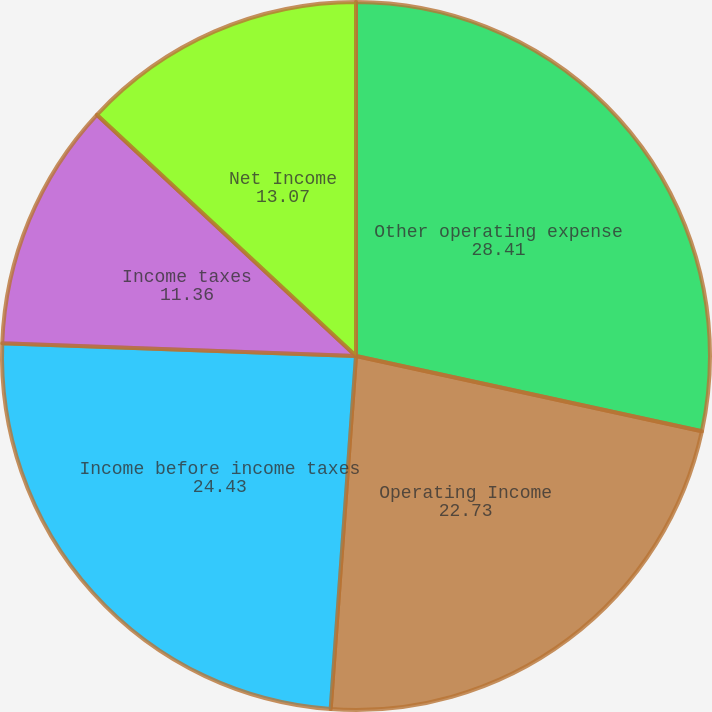Convert chart. <chart><loc_0><loc_0><loc_500><loc_500><pie_chart><fcel>Other operating expense<fcel>Operating Income<fcel>Income before income taxes<fcel>Income taxes<fcel>Net Income<nl><fcel>28.41%<fcel>22.73%<fcel>24.43%<fcel>11.36%<fcel>13.07%<nl></chart> 